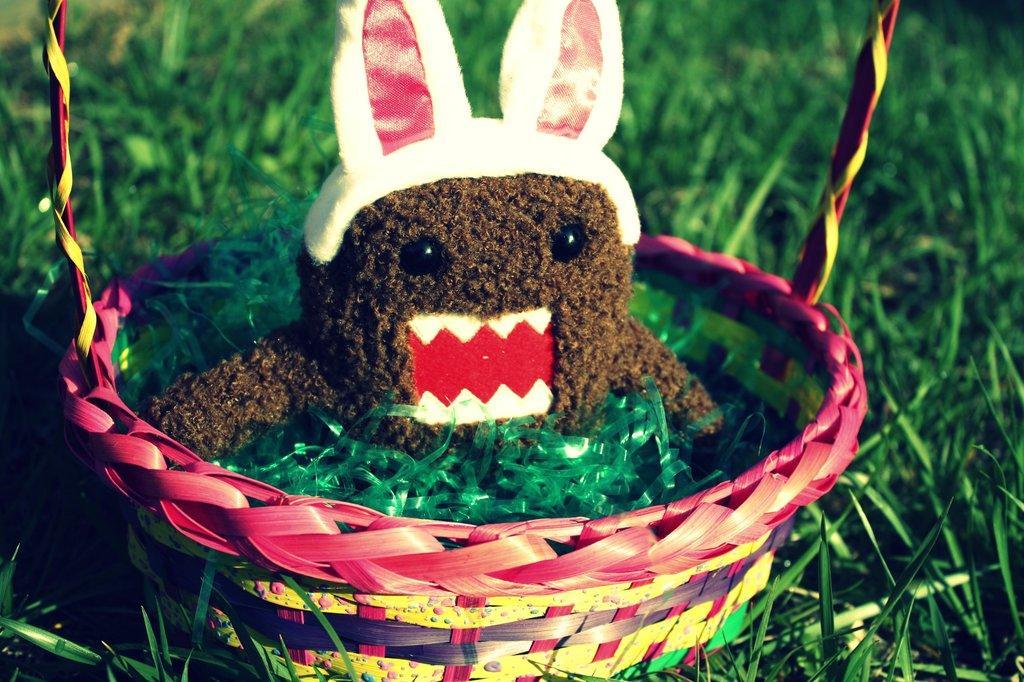Describe this image in one or two sentences. In the foreground of this image, there is a basket and there is a doll and few green stripe in it. In the background, there is the grass. 